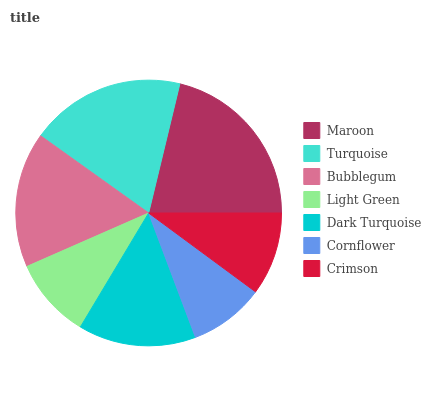Is Cornflower the minimum?
Answer yes or no. Yes. Is Maroon the maximum?
Answer yes or no. Yes. Is Turquoise the minimum?
Answer yes or no. No. Is Turquoise the maximum?
Answer yes or no. No. Is Maroon greater than Turquoise?
Answer yes or no. Yes. Is Turquoise less than Maroon?
Answer yes or no. Yes. Is Turquoise greater than Maroon?
Answer yes or no. No. Is Maroon less than Turquoise?
Answer yes or no. No. Is Dark Turquoise the high median?
Answer yes or no. Yes. Is Dark Turquoise the low median?
Answer yes or no. Yes. Is Bubblegum the high median?
Answer yes or no. No. Is Crimson the low median?
Answer yes or no. No. 